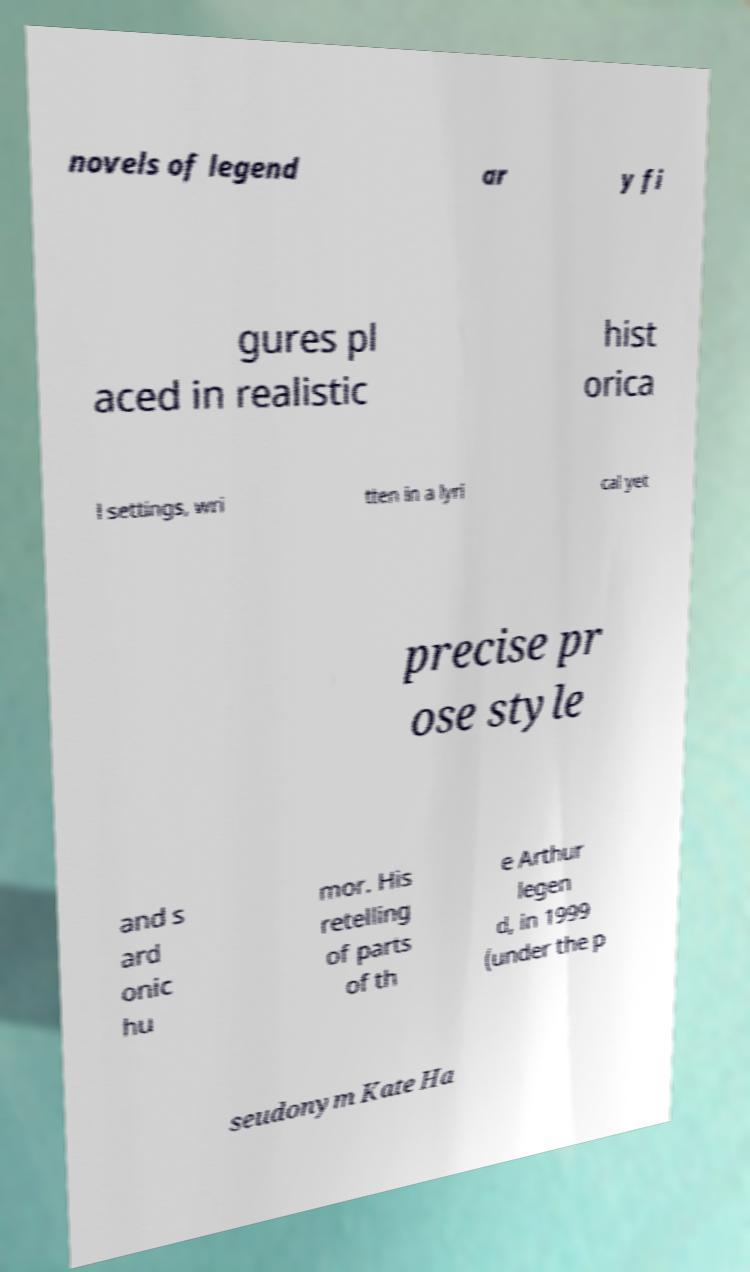I need the written content from this picture converted into text. Can you do that? novels of legend ar y fi gures pl aced in realistic hist orica l settings, wri tten in a lyri cal yet precise pr ose style and s ard onic hu mor. His retelling of parts of th e Arthur legen d, in 1999 (under the p seudonym Kate Ha 